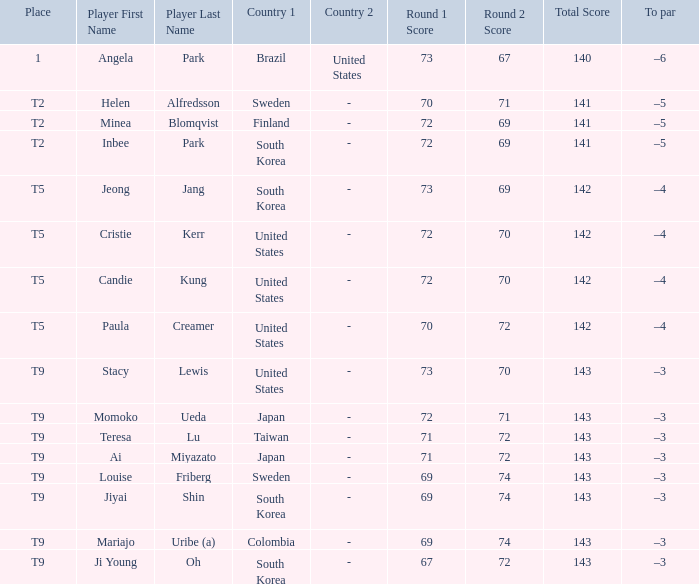Could you help me parse every detail presented in this table? {'header': ['Place', 'Player First Name', 'Player Last Name', 'Country 1', 'Country 2', 'Round 1 Score', 'Round 2 Score', 'Total Score', 'To par'], 'rows': [['1', 'Angela', 'Park', 'Brazil', 'United States', '73', '67', '140', '–6'], ['T2', 'Helen', 'Alfredsson', 'Sweden', '-', '70', '71', '141', '–5'], ['T2', 'Minea', 'Blomqvist', 'Finland', '-', '72', '69', '141', '–5'], ['T2', 'Inbee', 'Park', 'South Korea', '-', '72', '69', '141', '–5'], ['T5', 'Jeong', 'Jang', 'South Korea', '-', '73', '69', '142', '–4'], ['T5', 'Cristie', 'Kerr', 'United States', '-', '72', '70', '142', '–4'], ['T5', 'Candie', 'Kung', 'United States', '-', '72', '70', '142', '–4'], ['T5', 'Paula', 'Creamer', 'United States', '-', '70', '72', '142', '–4'], ['T9', 'Stacy', 'Lewis', 'United States', '-', '73', '70', '143', '–3'], ['T9', 'Momoko', 'Ueda', 'Japan', '-', '72', '71', '143', '–3'], ['T9', 'Teresa', 'Lu', 'Taiwan', '-', '71', '72', '143', '–3'], ['T9', 'Ai', 'Miyazato', 'Japan', '-', '71', '72', '143', '–3'], ['T9', 'Louise', 'Friberg', 'Sweden', '-', '69', '74', '143', '–3'], ['T9', 'Jiyai', 'Shin', 'South Korea', '-', '69', '74', '143', '–3'], ['T9', 'Mariajo', 'Uribe (a)', 'Colombia', '-', '69', '74', '143', '–3'], ['T9', 'Ji Young', 'Oh', 'South Korea', '-', '67', '72', '143', '–3']]} Who scored 69-74=143 for Colombia? Mariajo Uribe (a). 